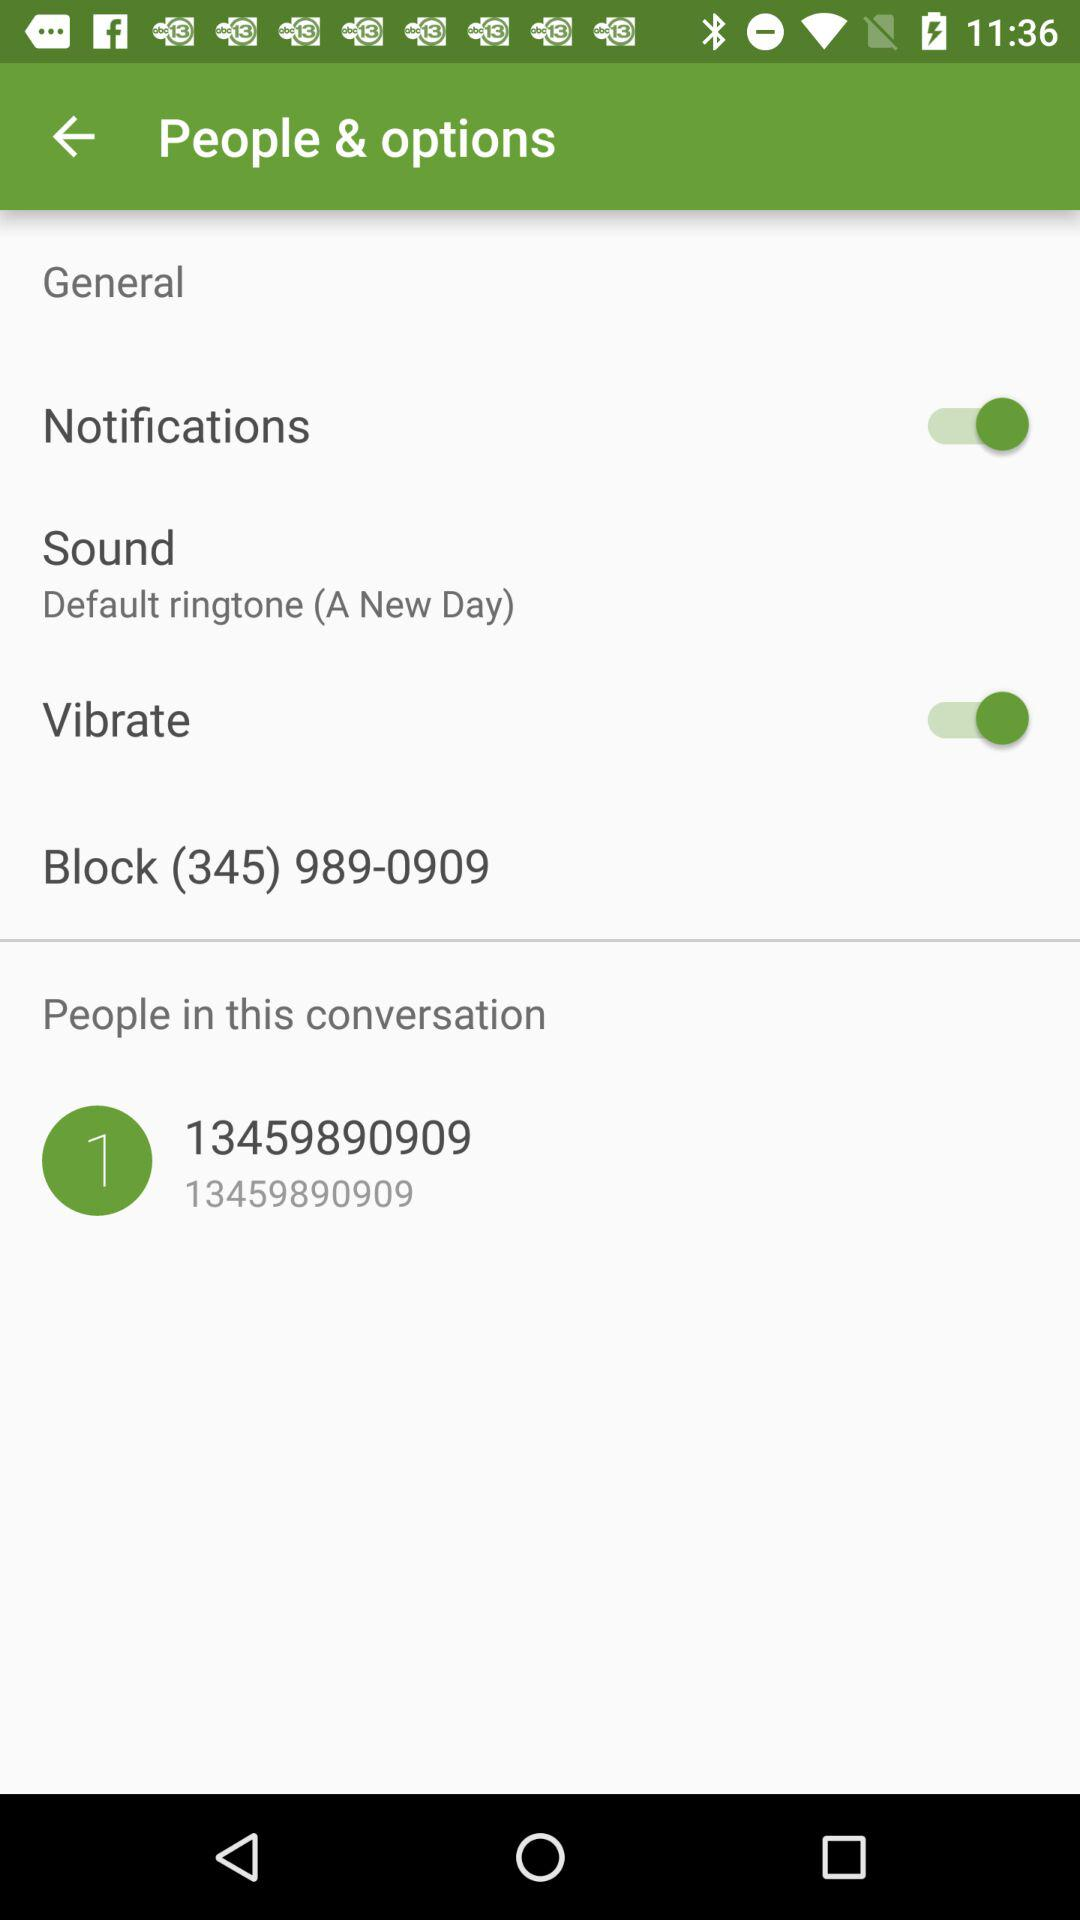What is the status of "Notifications"? The status is "on". 